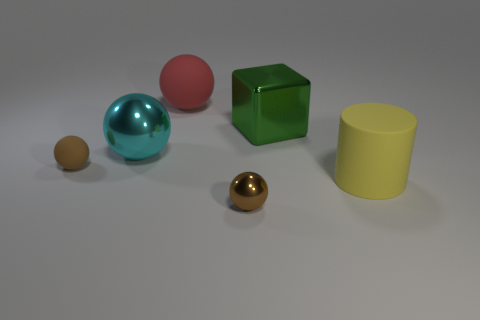Is there anything else that has the same shape as the green object?
Provide a short and direct response. No. There is another sphere that is the same size as the cyan metallic sphere; what is its material?
Offer a very short reply. Rubber. There is a shiny thing that is on the right side of the large cyan metal ball and behind the large yellow rubber cylinder; what shape is it?
Your answer should be very brief. Cube. There is a matte ball behind the large metal cube; what color is it?
Your answer should be very brief. Red. What is the size of the thing that is both behind the big yellow cylinder and right of the big red thing?
Offer a terse response. Large. Do the red sphere and the tiny brown object that is on the right side of the tiny brown matte object have the same material?
Make the answer very short. No. How many other large rubber things are the same shape as the cyan object?
Offer a terse response. 1. What material is the other tiny object that is the same color as the tiny shiny thing?
Make the answer very short. Rubber. What number of big blue cylinders are there?
Your response must be concise. 0. There is a yellow matte thing; is its shape the same as the metallic thing in front of the yellow matte cylinder?
Your response must be concise. No. 